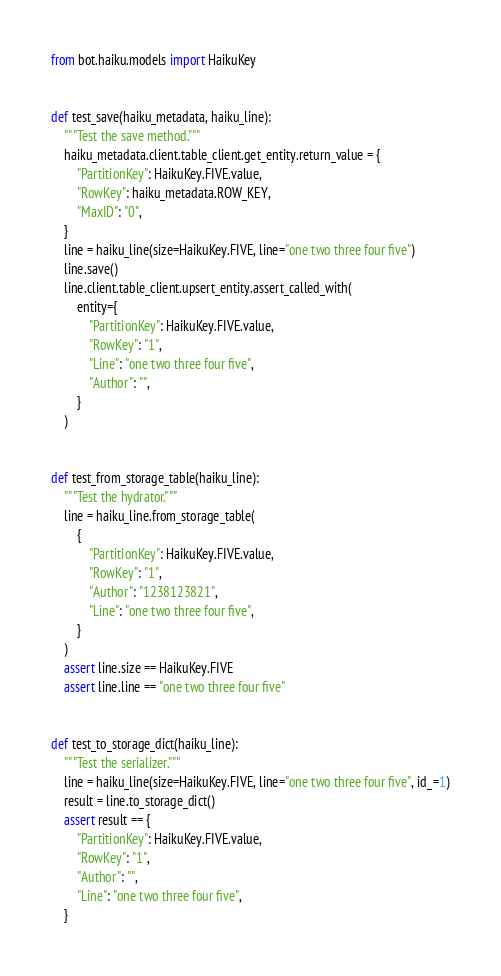<code> <loc_0><loc_0><loc_500><loc_500><_Python_>from bot.haiku.models import HaikuKey


def test_save(haiku_metadata, haiku_line):
    """Test the save method."""
    haiku_metadata.client.table_client.get_entity.return_value = {
        "PartitionKey": HaikuKey.FIVE.value,
        "RowKey": haiku_metadata.ROW_KEY,
        "MaxID": "0",
    }
    line = haiku_line(size=HaikuKey.FIVE, line="one two three four five")
    line.save()
    line.client.table_client.upsert_entity.assert_called_with(
        entity={
            "PartitionKey": HaikuKey.FIVE.value,
            "RowKey": "1",
            "Line": "one two three four five",
            "Author": "",
        }
    )


def test_from_storage_table(haiku_line):
    """Test the hydrator."""
    line = haiku_line.from_storage_table(
        {
            "PartitionKey": HaikuKey.FIVE.value,
            "RowKey": "1",
            "Author": "1238123821",
            "Line": "one two three four five",
        }
    )
    assert line.size == HaikuKey.FIVE
    assert line.line == "one two three four five"


def test_to_storage_dict(haiku_line):
    """Test the serializer."""
    line = haiku_line(size=HaikuKey.FIVE, line="one two three four five", id_=1)
    result = line.to_storage_dict()
    assert result == {
        "PartitionKey": HaikuKey.FIVE.value,
        "RowKey": "1",
        "Author": "",
        "Line": "one two three four five",
    }
</code> 